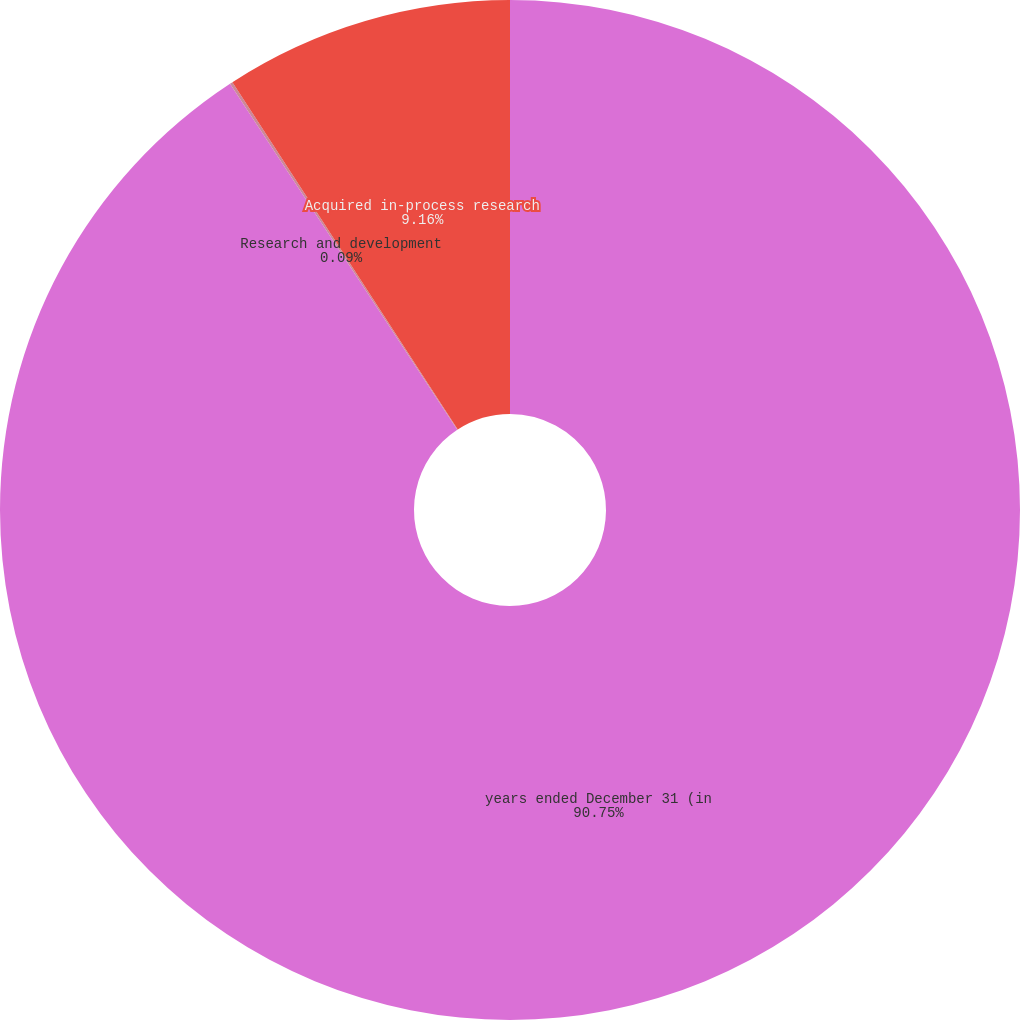<chart> <loc_0><loc_0><loc_500><loc_500><pie_chart><fcel>years ended December 31 (in<fcel>Research and development<fcel>Acquired in-process research<nl><fcel>90.75%<fcel>0.09%<fcel>9.16%<nl></chart> 